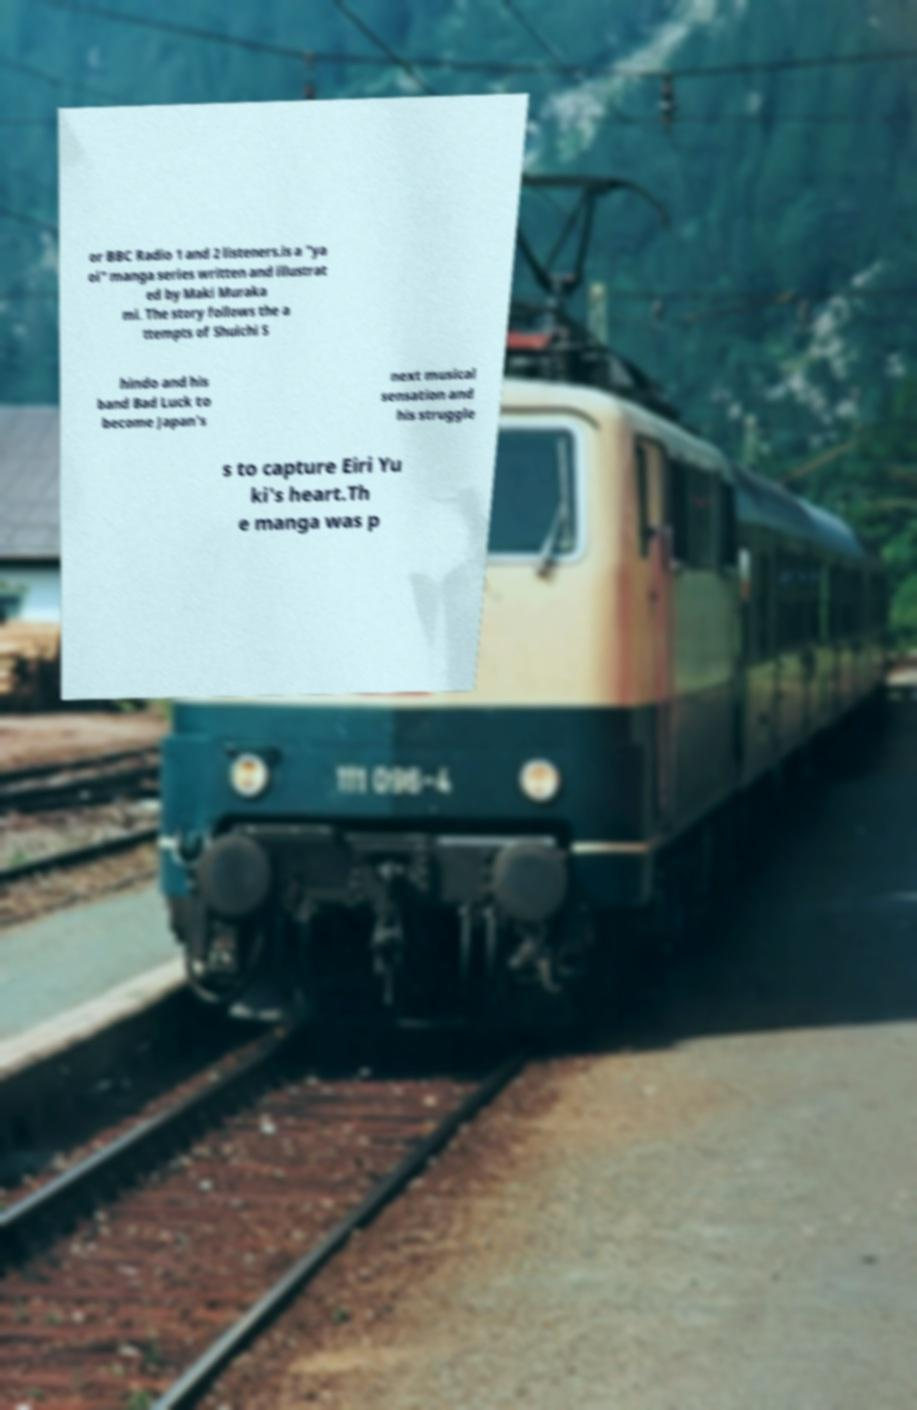Could you extract and type out the text from this image? or BBC Radio 1 and 2 listeners.is a "ya oi" manga series written and illustrat ed by Maki Muraka mi. The story follows the a ttempts of Shuichi S hindo and his band Bad Luck to become Japan's next musical sensation and his struggle s to capture Eiri Yu ki's heart.Th e manga was p 